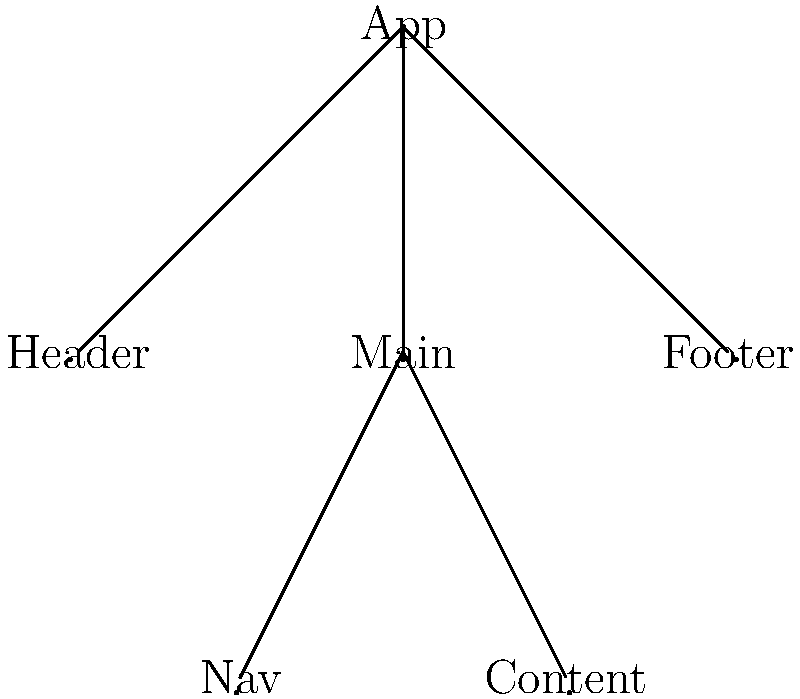As a startup founder, you're discussing the component hierarchy of your frontend framework with your software architect. Given the tree structure above, what is the maximum depth of the component tree, and how many direct children does the "Main" component have? To answer this question, we need to analyze the component hierarchy represented in the tree structure:

1. Determine the depth of the tree:
   - The root node is "App" at level 0.
   - "Header", "Main", and "Footer" are at level 1.
   - "Nav" and "Content" are at level 2.
   - There are no nodes below level 2.
   - Therefore, the maximum depth is 2 (counting from 0).

2. Count the direct children of the "Main" component:
   - The "Main" component is connected directly to "Nav" and "Content".
   - There are no other components directly connected to "Main".
   - Therefore, "Main" has 2 direct children.

3. Combine the information:
   - Maximum depth: 2
   - Number of direct children of "Main": 2

The answer can be expressed as an ordered pair $(2, 2)$, where the first number represents the maximum depth and the second number represents the number of direct children of the "Main" component.
Answer: $(2, 2)$ 